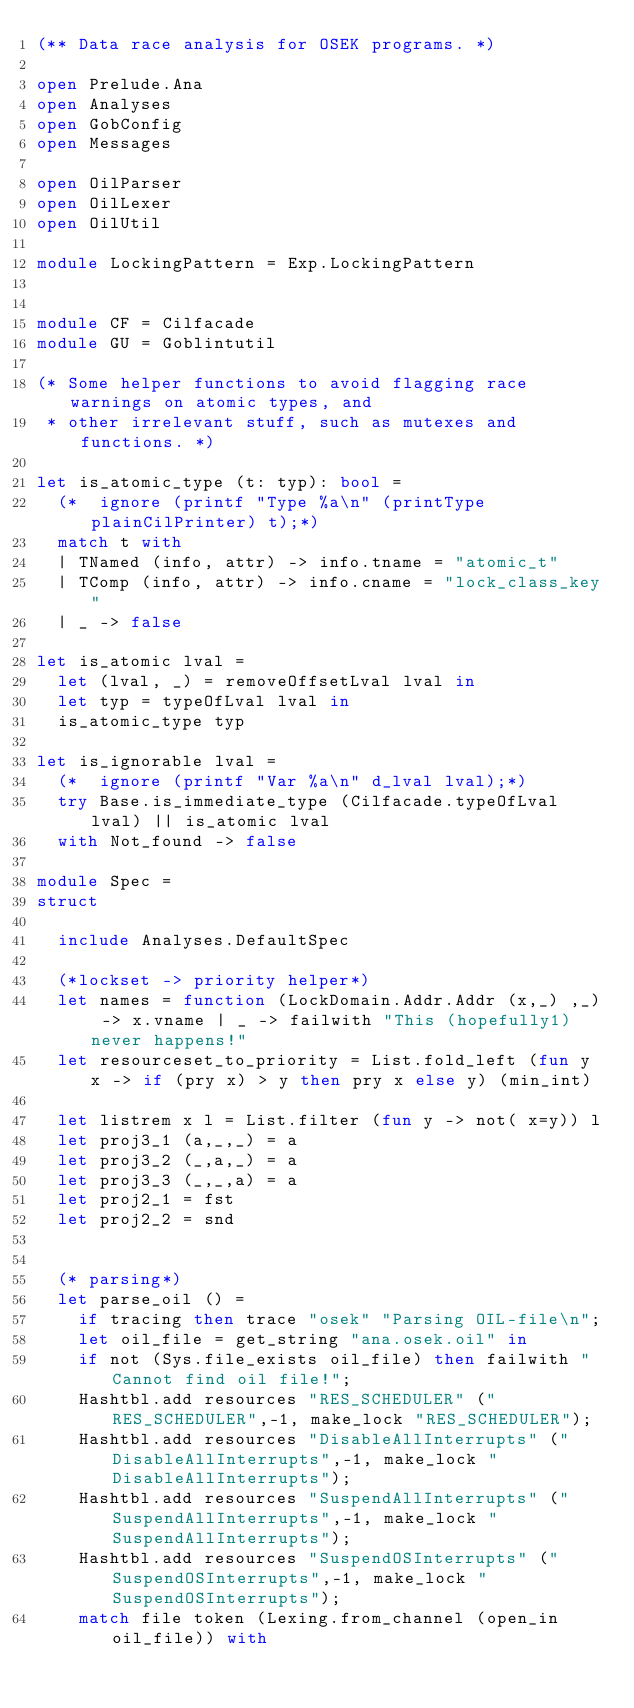<code> <loc_0><loc_0><loc_500><loc_500><_OCaml_>(** Data race analysis for OSEK programs. *)

open Prelude.Ana
open Analyses
open GobConfig
open Messages

open OilParser
open OilLexer
open OilUtil

module LockingPattern = Exp.LockingPattern


module CF = Cilfacade
module GU = Goblintutil

(* Some helper functions to avoid flagging race warnings on atomic types, and
 * other irrelevant stuff, such as mutexes and functions. *)

let is_atomic_type (t: typ): bool =
  (*  ignore (printf "Type %a\n" (printType plainCilPrinter) t);*)
  match t with
  | TNamed (info, attr) -> info.tname = "atomic_t"
  | TComp (info, attr) -> info.cname = "lock_class_key"
  | _ -> false

let is_atomic lval =
  let (lval, _) = removeOffsetLval lval in
  let typ = typeOfLval lval in
  is_atomic_type typ

let is_ignorable lval =
  (*  ignore (printf "Var %a\n" d_lval lval);*)
  try Base.is_immediate_type (Cilfacade.typeOfLval lval) || is_atomic lval
  with Not_found -> false

module Spec =
struct

  include Analyses.DefaultSpec

  (*lockset -> priority helper*)
  let names = function (LockDomain.Addr.Addr (x,_) ,_) -> x.vname | _ -> failwith "This (hopefully1) never happens!"
  let resourceset_to_priority = List.fold_left (fun y x -> if (pry x) > y then pry x else y) (min_int)

  let listrem x l = List.filter (fun y -> not( x=y)) l
  let proj3_1 (a,_,_) = a
  let proj3_2 (_,a,_) = a
  let proj3_3 (_,_,a) = a
  let proj2_1 = fst
  let proj2_2 = snd


  (* parsing*)
  let parse_oil () =
    if tracing then trace "osek" "Parsing OIL-file\n";
    let oil_file = get_string "ana.osek.oil" in
    if not (Sys.file_exists oil_file) then failwith "Cannot find oil file!";
    Hashtbl.add resources "RES_SCHEDULER" ("RES_SCHEDULER",-1, make_lock "RES_SCHEDULER");
    Hashtbl.add resources "DisableAllInterrupts" ("DisableAllInterrupts",-1, make_lock "DisableAllInterrupts");
    Hashtbl.add resources "SuspendAllInterrupts" ("SuspendAllInterrupts",-1, make_lock "SuspendAllInterrupts");
    Hashtbl.add resources "SuspendOSInterrupts" ("SuspendOSInterrupts",-1, make_lock "SuspendOSInterrupts");
    match file token (Lexing.from_channel (open_in oil_file)) with</code> 